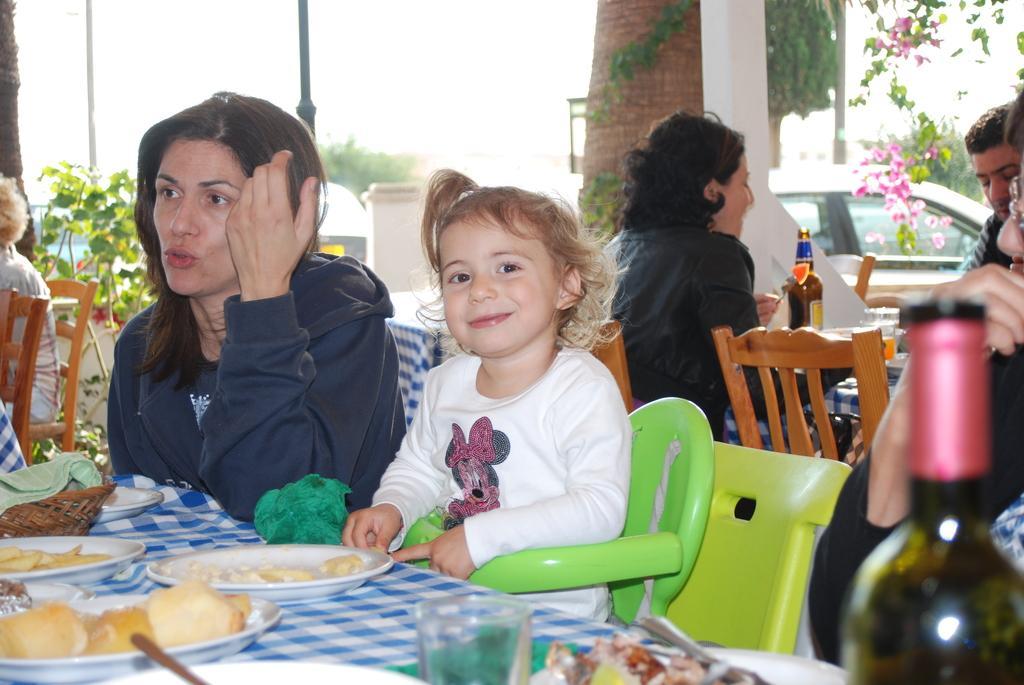Please provide a concise description of this image. Here in the front we can see a Woman and a Child sitting on chairs and they have food in front of them on the plates placed on the table and behind them there are a couple of people who are also having food and a bottle is placed on the table and at the right side we can see a car and there is a tree behind that 